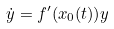Convert formula to latex. <formula><loc_0><loc_0><loc_500><loc_500>\dot { y } = f ^ { \prime } ( { x } _ { 0 } ( t ) ) y</formula> 